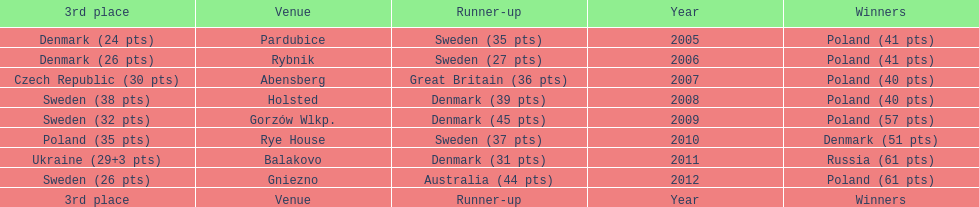After their first place win in 2009, how did poland place the next year at the speedway junior world championship? 3rd place. 